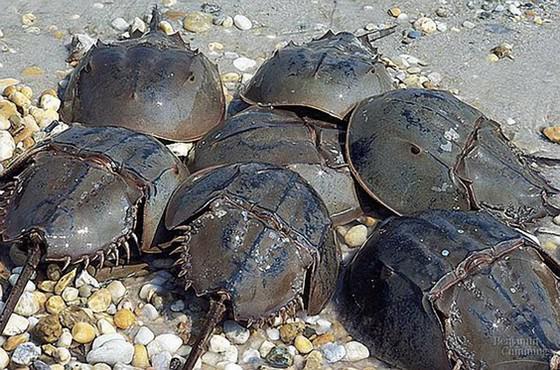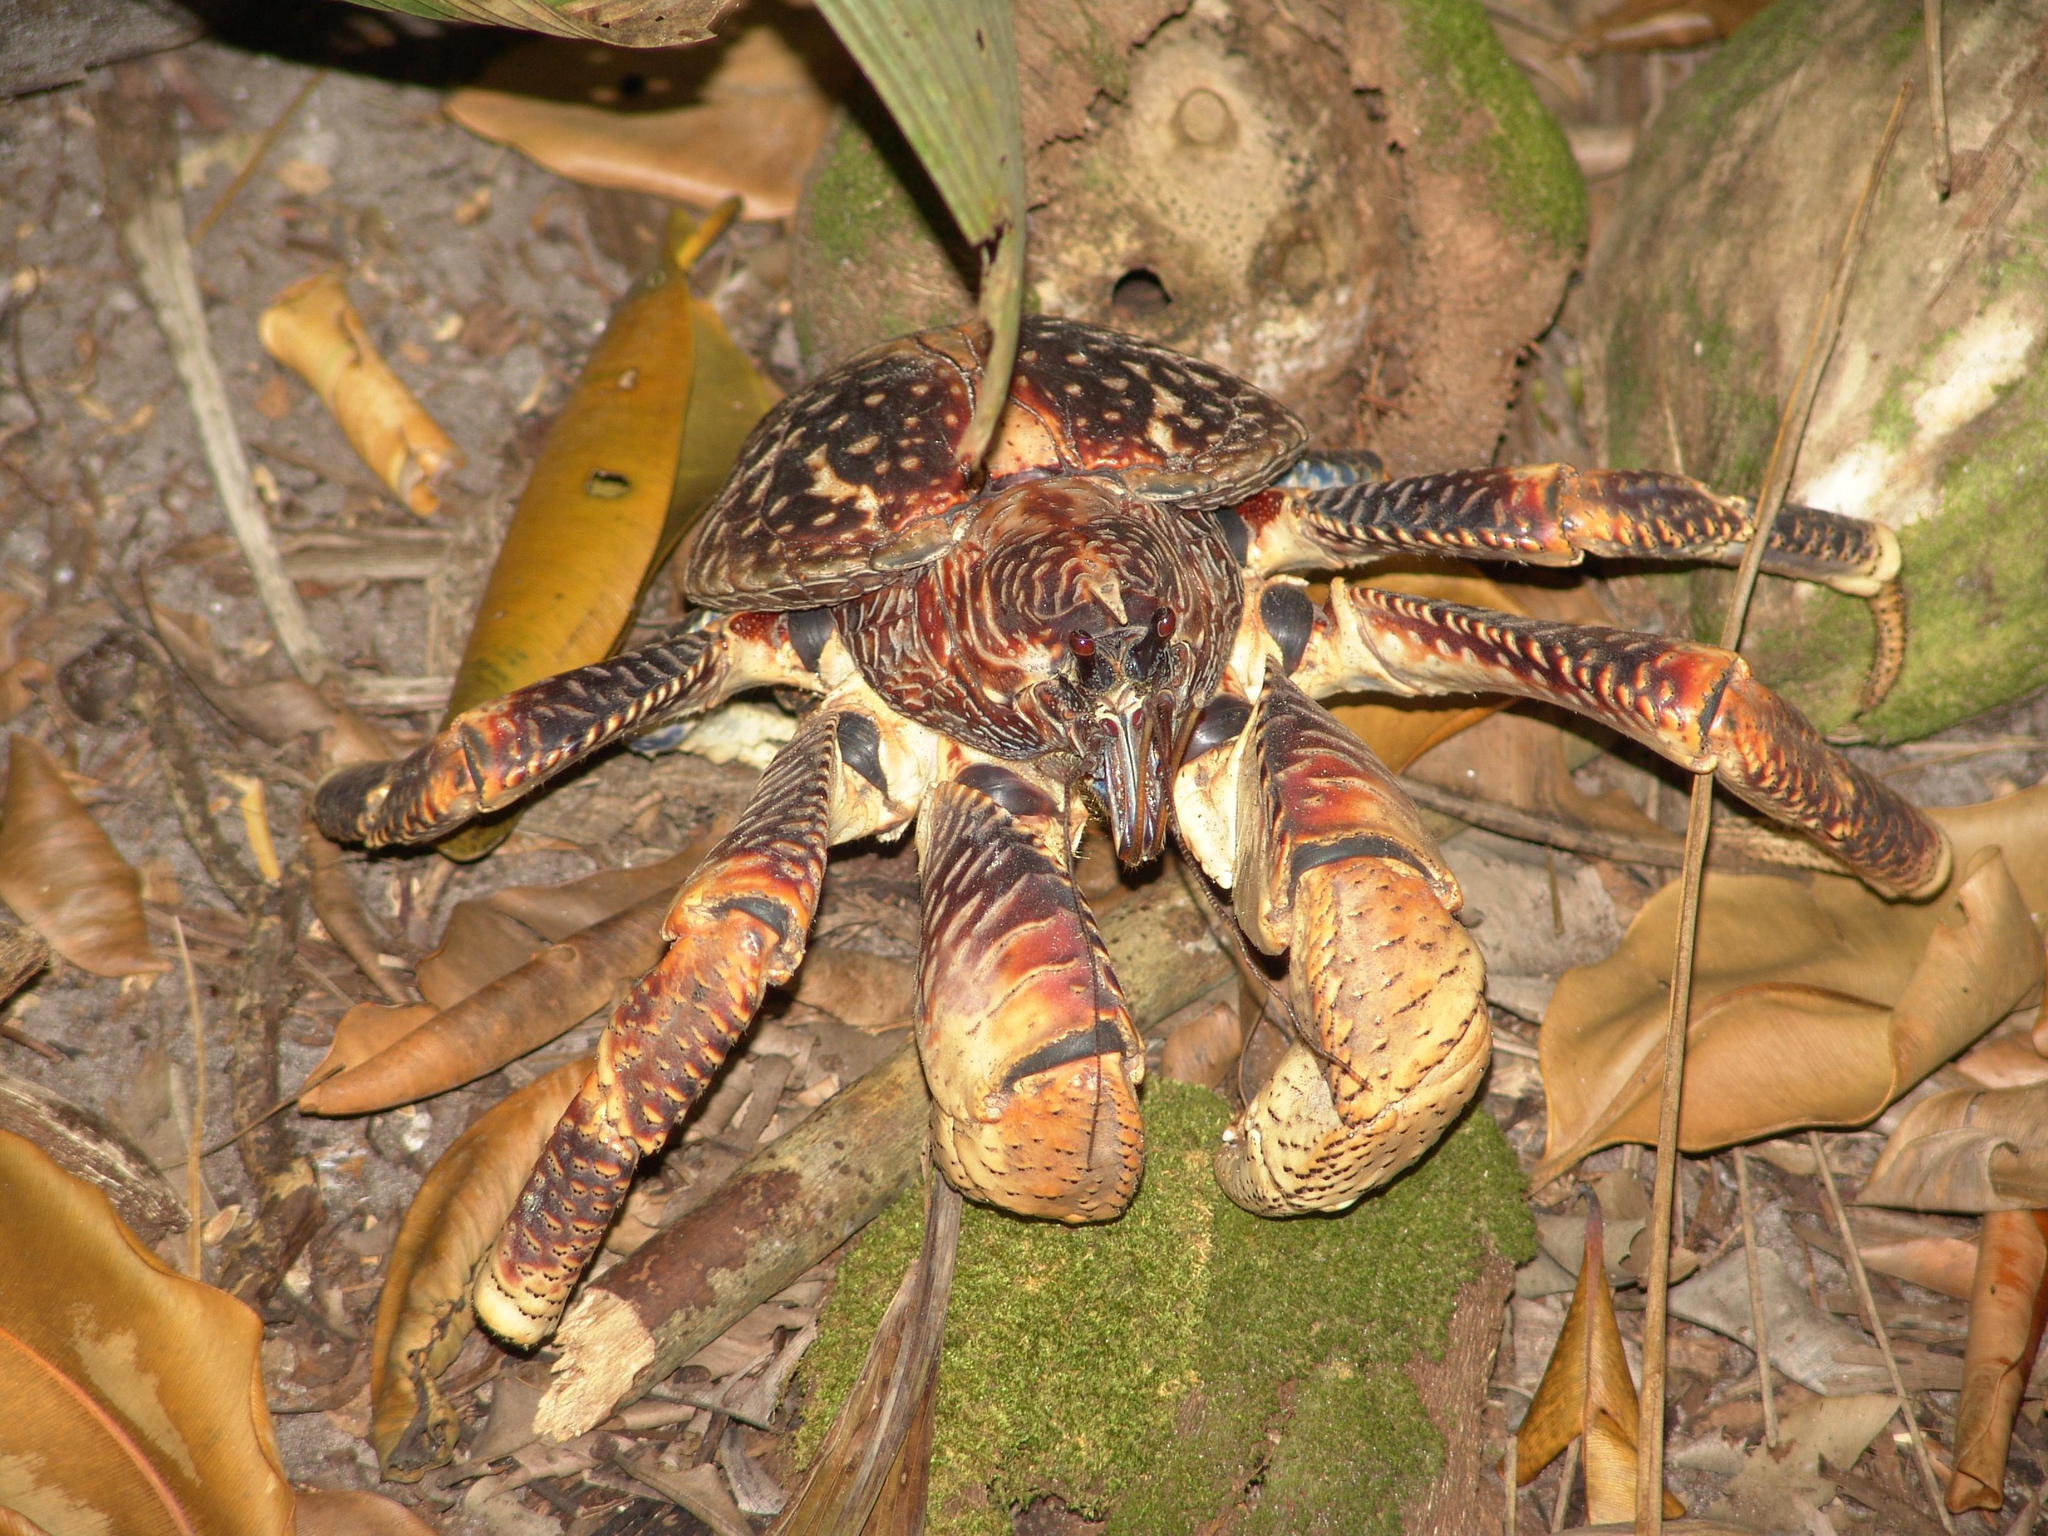The first image is the image on the left, the second image is the image on the right. Evaluate the accuracy of this statement regarding the images: "The right image contains one animal.". Is it true? Answer yes or no. Yes. The first image is the image on the left, the second image is the image on the right. Analyze the images presented: Is the assertion "Eight or fewer crabs are visible." valid? Answer yes or no. Yes. 